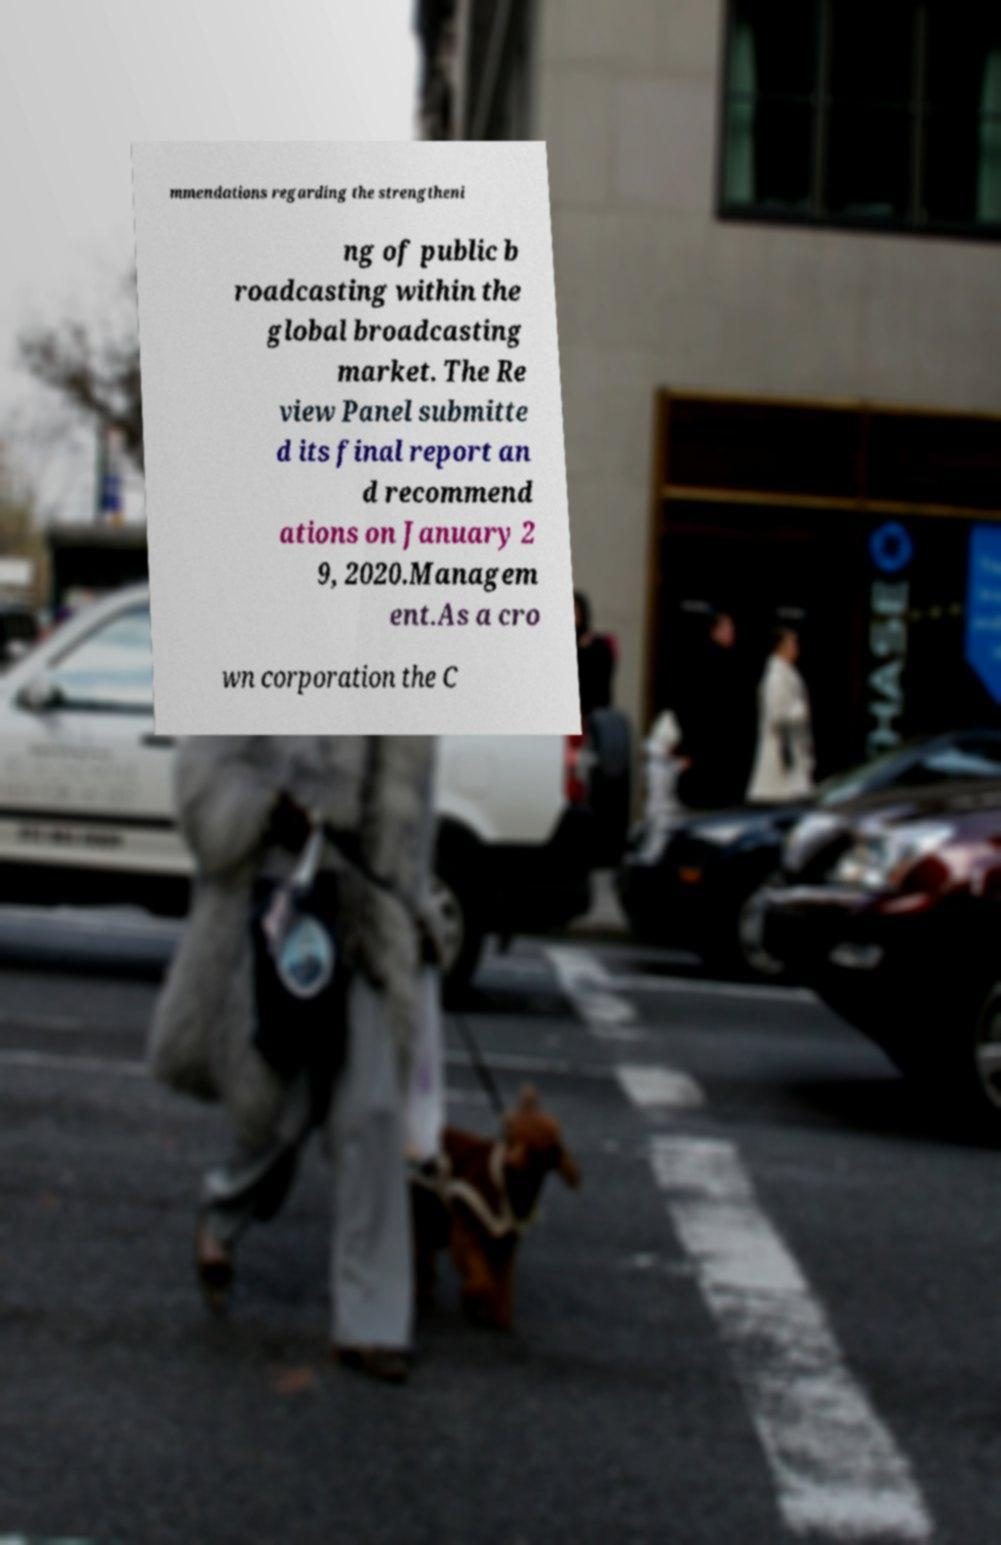Please identify and transcribe the text found in this image. mmendations regarding the strengtheni ng of public b roadcasting within the global broadcasting market. The Re view Panel submitte d its final report an d recommend ations on January 2 9, 2020.Managem ent.As a cro wn corporation the C 